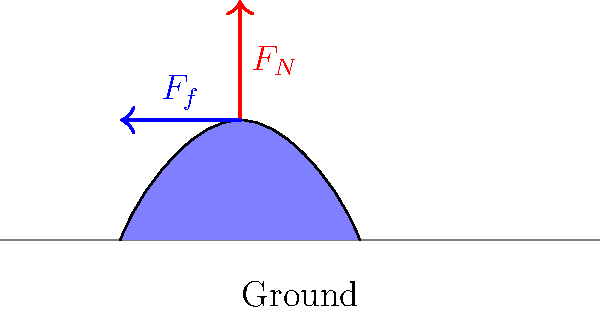During a traditional Chinese lion dance performance, the dancer's foot exerts a force on the ground. Consider the moment when the dancer's foot is flat on the ground, as shown in the diagram. If the normal force ($F_N$) is 800 N and the coefficient of static friction ($\mu_s$) between the foot and the ground is 0.6, what is the maximum horizontal force ($F_f$) that can be applied before the foot starts to slip? To solve this problem, we'll follow these steps:

1. Recall the formula for maximum static friction force:
   $F_f \leq \mu_s F_N$

2. We are given:
   - Normal force $F_N = 800$ N
   - Coefficient of static friction $\mu_s = 0.6$

3. Substitute the values into the formula:
   $F_f \leq 0.6 \times 800$ N

4. Calculate the maximum friction force:
   $F_f \leq 480$ N

Therefore, the maximum horizontal force that can be applied before the foot starts to slip is 480 N. This force allows the dancer to maintain stability and perform intricate movements during the lion dance, showcasing the strength and skill of Chinese cultural performances.
Answer: 480 N 